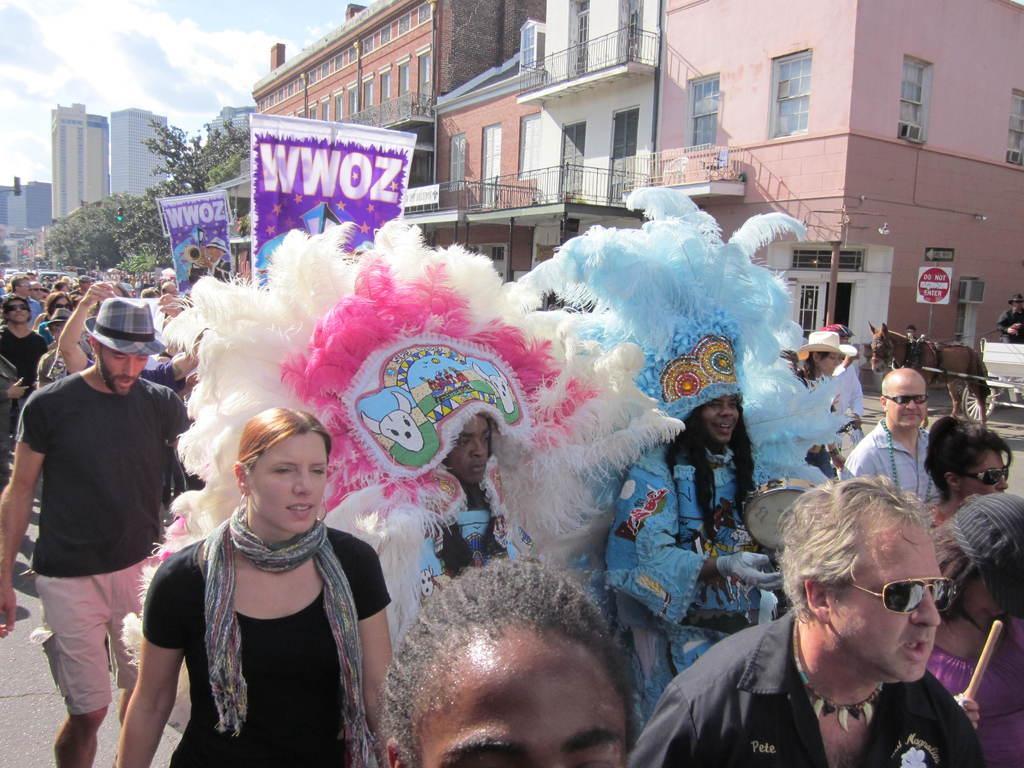Please provide a concise description of this image. In this picture there are people in the center of the image, by holding posters in their hands and some of them are wearing costumes and there are buildings and trees in the background area of the image, it seems to be a march. 